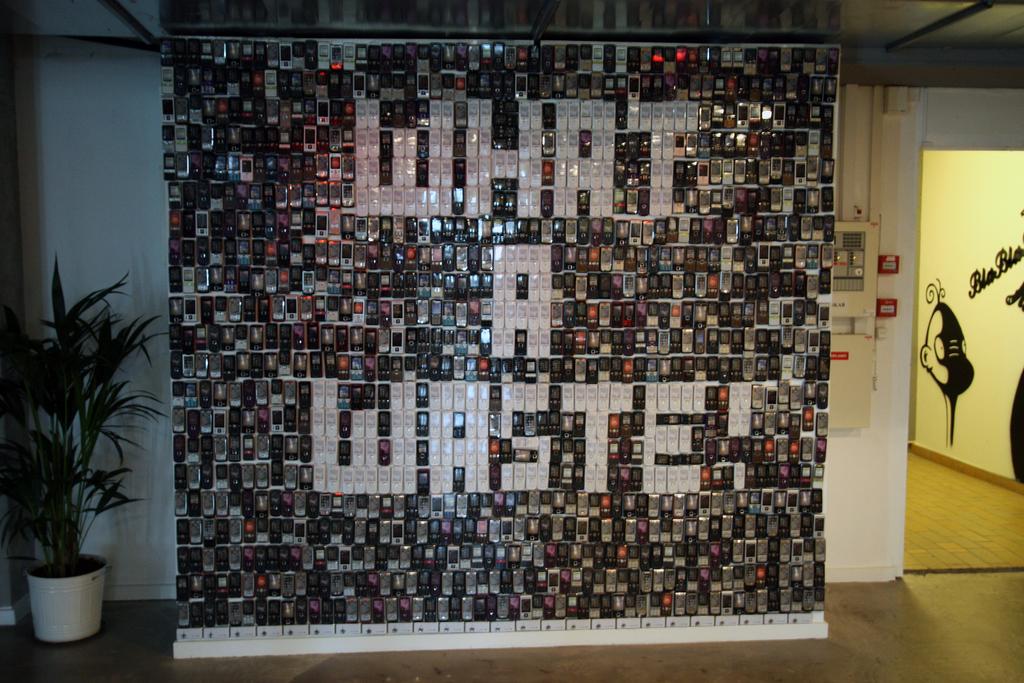What do the white letters say?
Give a very brief answer. What a waste!. What is the letter in the second row?
Keep it short and to the point. A. 